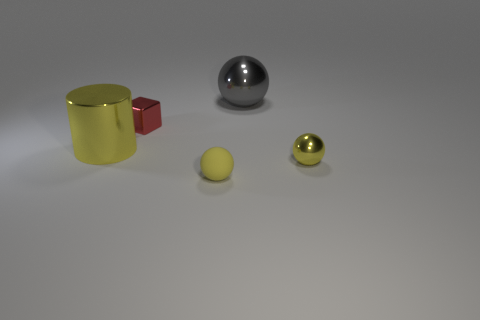Subtract all shiny balls. How many balls are left? 1 Subtract all gray spheres. How many spheres are left? 2 Subtract all spheres. How many objects are left? 2 Subtract 2 spheres. How many spheres are left? 1 Subtract all cyan blocks. How many gray spheres are left? 1 Subtract all large cyan metal spheres. Subtract all yellow spheres. How many objects are left? 3 Add 4 large gray spheres. How many large gray spheres are left? 5 Add 1 big gray spheres. How many big gray spheres exist? 2 Add 4 yellow metallic balls. How many objects exist? 9 Subtract 0 green cylinders. How many objects are left? 5 